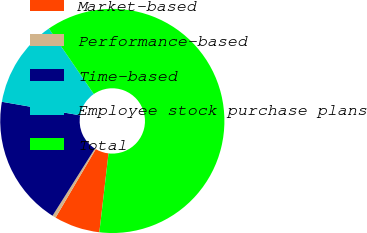Convert chart. <chart><loc_0><loc_0><loc_500><loc_500><pie_chart><fcel>Market-based<fcel>Performance-based<fcel>Time-based<fcel>Employee stock purchase plans<fcel>Total<nl><fcel>6.6%<fcel>0.51%<fcel>18.78%<fcel>12.69%<fcel>61.42%<nl></chart> 